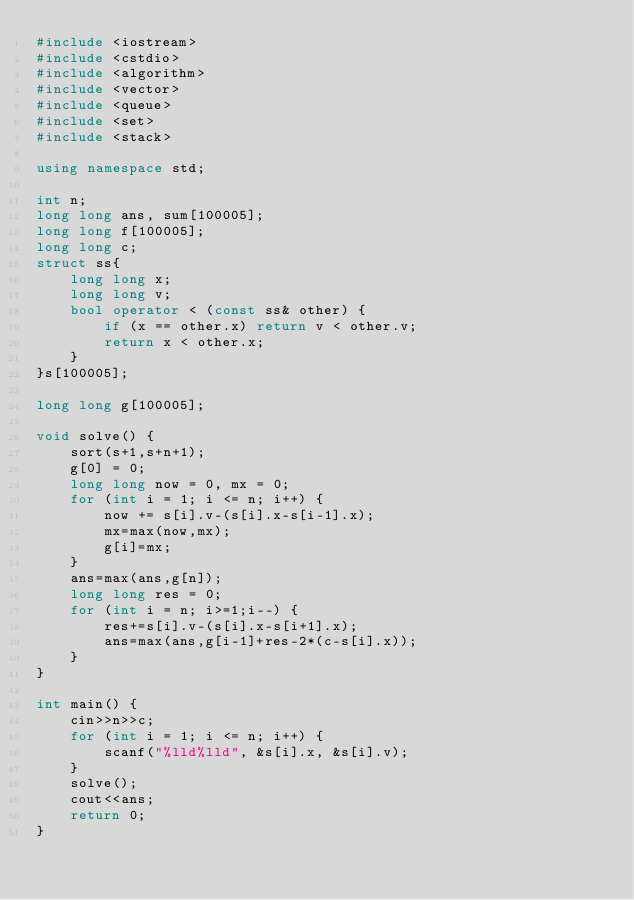Convert code to text. <code><loc_0><loc_0><loc_500><loc_500><_C++_>#include <iostream>
#include <cstdio>
#include <algorithm>
#include <vector>
#include <queue>
#include <set>
#include <stack>

using namespace std;

int n;
long long ans, sum[100005];
long long f[100005];
long long c;
struct ss{
    long long x;
    long long v;
    bool operator < (const ss& other) {
        if (x == other.x) return v < other.v;
        return x < other.x;
    }
}s[100005];

long long g[100005];

void solve() {
    sort(s+1,s+n+1);
    g[0] = 0;
    long long now = 0, mx = 0;
    for (int i = 1; i <= n; i++) {
        now += s[i].v-(s[i].x-s[i-1].x);
        mx=max(now,mx);
        g[i]=mx;
    }
    ans=max(ans,g[n]);
    long long res = 0;
    for (int i = n; i>=1;i--) {
        res+=s[i].v-(s[i].x-s[i+1].x);
        ans=max(ans,g[i-1]+res-2*(c-s[i].x));
    }
}

int main() {
    cin>>n>>c;
    for (int i = 1; i <= n; i++) {
        scanf("%lld%lld", &s[i].x, &s[i].v);
    }
    solve();
    cout<<ans;
    return 0;
}</code> 